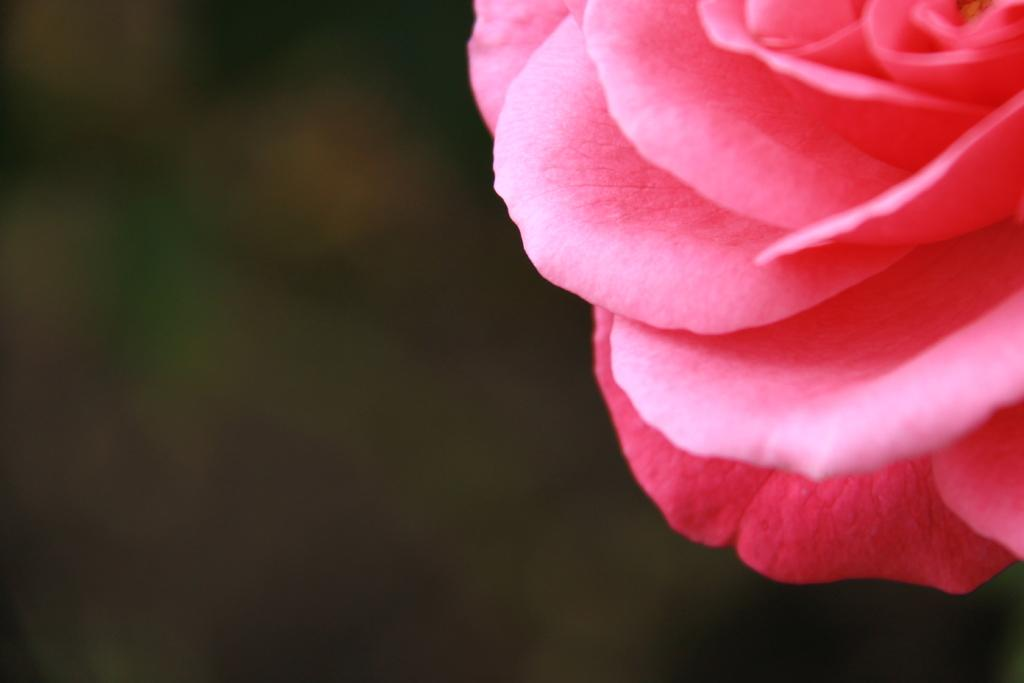What is the main subject in the foreground of the image? There is a flower in the foreground of the image. Can you describe the background of the image? The background of the image is blurry. What type of farm can be seen in the background of the image? There is no farm present in the image; the background is blurry. What design elements are present in the flower? The question about design elements is not relevant to the image, as it only contains a flower and a blurry background. 